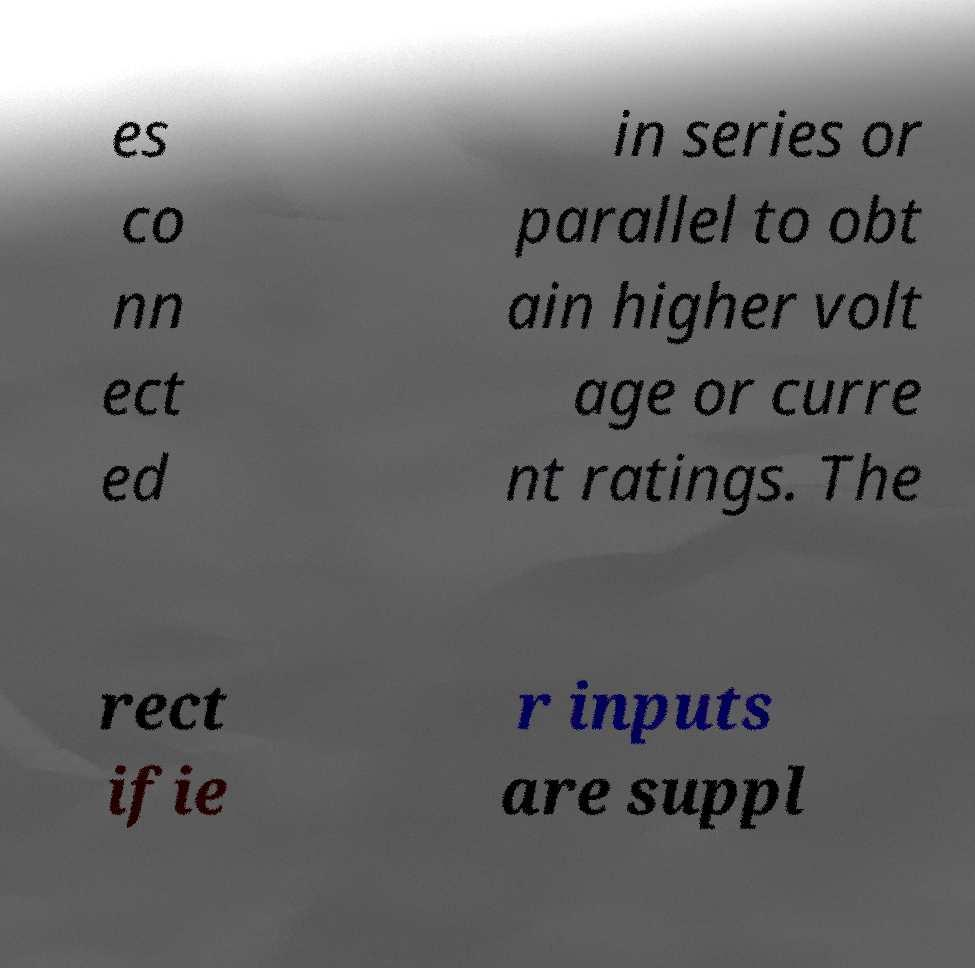For documentation purposes, I need the text within this image transcribed. Could you provide that? es co nn ect ed in series or parallel to obt ain higher volt age or curre nt ratings. The rect ifie r inputs are suppl 